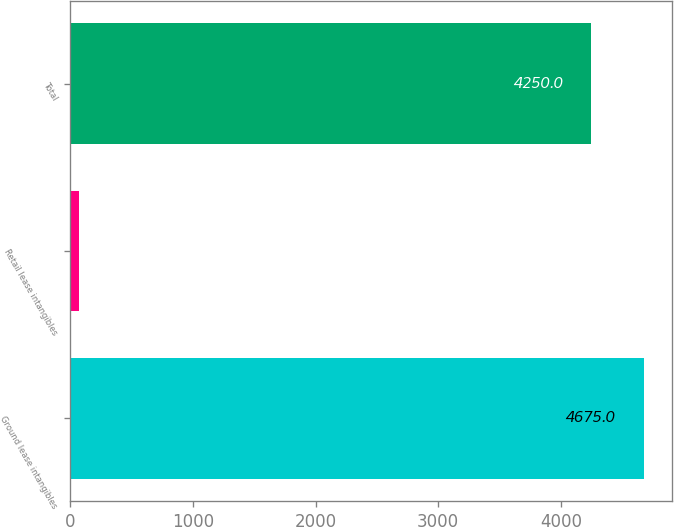Convert chart. <chart><loc_0><loc_0><loc_500><loc_500><bar_chart><fcel>Ground lease intangibles<fcel>Retail lease intangibles<fcel>Total<nl><fcel>4675<fcel>71<fcel>4250<nl></chart> 